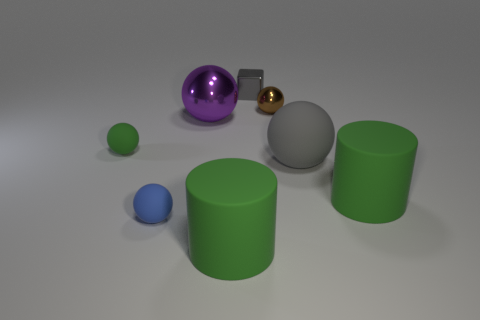There is a small matte sphere that is behind the big matte ball that is right of the thing that is behind the brown ball; what color is it?
Offer a very short reply. Green. What is the shape of the gray rubber object that is the same size as the purple object?
Give a very brief answer. Sphere. Are there more cubes than large cyan metallic cylinders?
Give a very brief answer. Yes. Is there a cylinder to the left of the large ball that is in front of the large purple shiny thing?
Ensure brevity in your answer.  Yes. What color is the large metallic object that is the same shape as the tiny blue rubber thing?
Your answer should be compact. Purple. Are there any other things that have the same shape as the small gray object?
Give a very brief answer. No. The other small object that is made of the same material as the brown thing is what color?
Offer a very short reply. Gray. There is a metallic ball in front of the small brown object that is behind the gray sphere; are there any big shiny things behind it?
Offer a very short reply. No. Are there fewer gray spheres on the left side of the big gray object than small things that are behind the large purple metallic thing?
Offer a terse response. Yes. What number of cylinders have the same material as the purple object?
Offer a very short reply. 0. 